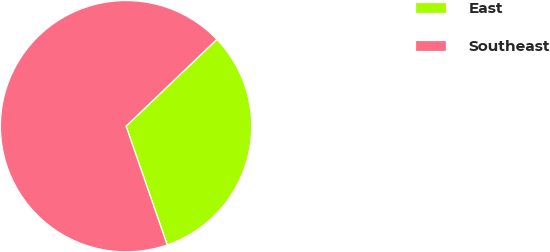<chart> <loc_0><loc_0><loc_500><loc_500><pie_chart><fcel>East<fcel>Southeast<nl><fcel>31.84%<fcel>68.16%<nl></chart> 